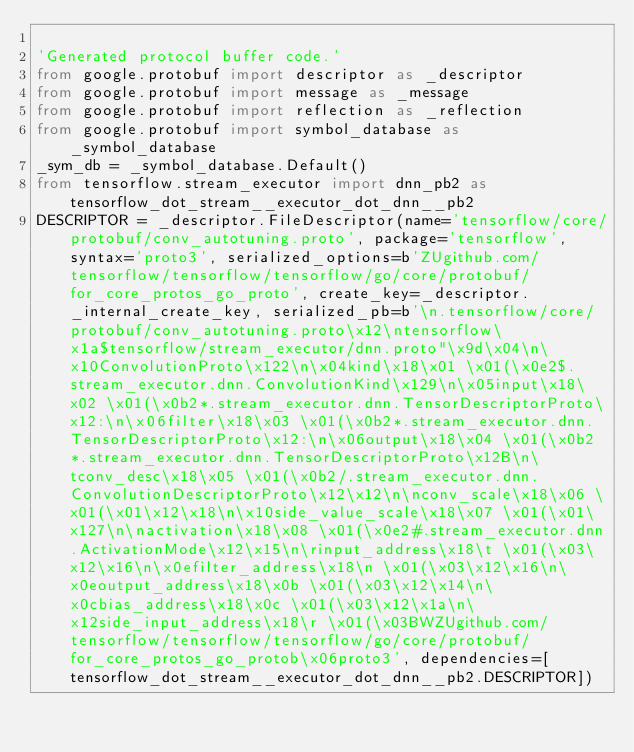Convert code to text. <code><loc_0><loc_0><loc_500><loc_500><_Python_>
'Generated protocol buffer code.'
from google.protobuf import descriptor as _descriptor
from google.protobuf import message as _message
from google.protobuf import reflection as _reflection
from google.protobuf import symbol_database as _symbol_database
_sym_db = _symbol_database.Default()
from tensorflow.stream_executor import dnn_pb2 as tensorflow_dot_stream__executor_dot_dnn__pb2
DESCRIPTOR = _descriptor.FileDescriptor(name='tensorflow/core/protobuf/conv_autotuning.proto', package='tensorflow', syntax='proto3', serialized_options=b'ZUgithub.com/tensorflow/tensorflow/tensorflow/go/core/protobuf/for_core_protos_go_proto', create_key=_descriptor._internal_create_key, serialized_pb=b'\n.tensorflow/core/protobuf/conv_autotuning.proto\x12\ntensorflow\x1a$tensorflow/stream_executor/dnn.proto"\x9d\x04\n\x10ConvolutionProto\x122\n\x04kind\x18\x01 \x01(\x0e2$.stream_executor.dnn.ConvolutionKind\x129\n\x05input\x18\x02 \x01(\x0b2*.stream_executor.dnn.TensorDescriptorProto\x12:\n\x06filter\x18\x03 \x01(\x0b2*.stream_executor.dnn.TensorDescriptorProto\x12:\n\x06output\x18\x04 \x01(\x0b2*.stream_executor.dnn.TensorDescriptorProto\x12B\n\tconv_desc\x18\x05 \x01(\x0b2/.stream_executor.dnn.ConvolutionDescriptorProto\x12\x12\n\nconv_scale\x18\x06 \x01(\x01\x12\x18\n\x10side_value_scale\x18\x07 \x01(\x01\x127\n\nactivation\x18\x08 \x01(\x0e2#.stream_executor.dnn.ActivationMode\x12\x15\n\rinput_address\x18\t \x01(\x03\x12\x16\n\x0efilter_address\x18\n \x01(\x03\x12\x16\n\x0eoutput_address\x18\x0b \x01(\x03\x12\x14\n\x0cbias_address\x18\x0c \x01(\x03\x12\x1a\n\x12side_input_address\x18\r \x01(\x03BWZUgithub.com/tensorflow/tensorflow/tensorflow/go/core/protobuf/for_core_protos_go_protob\x06proto3', dependencies=[tensorflow_dot_stream__executor_dot_dnn__pb2.DESCRIPTOR])</code> 